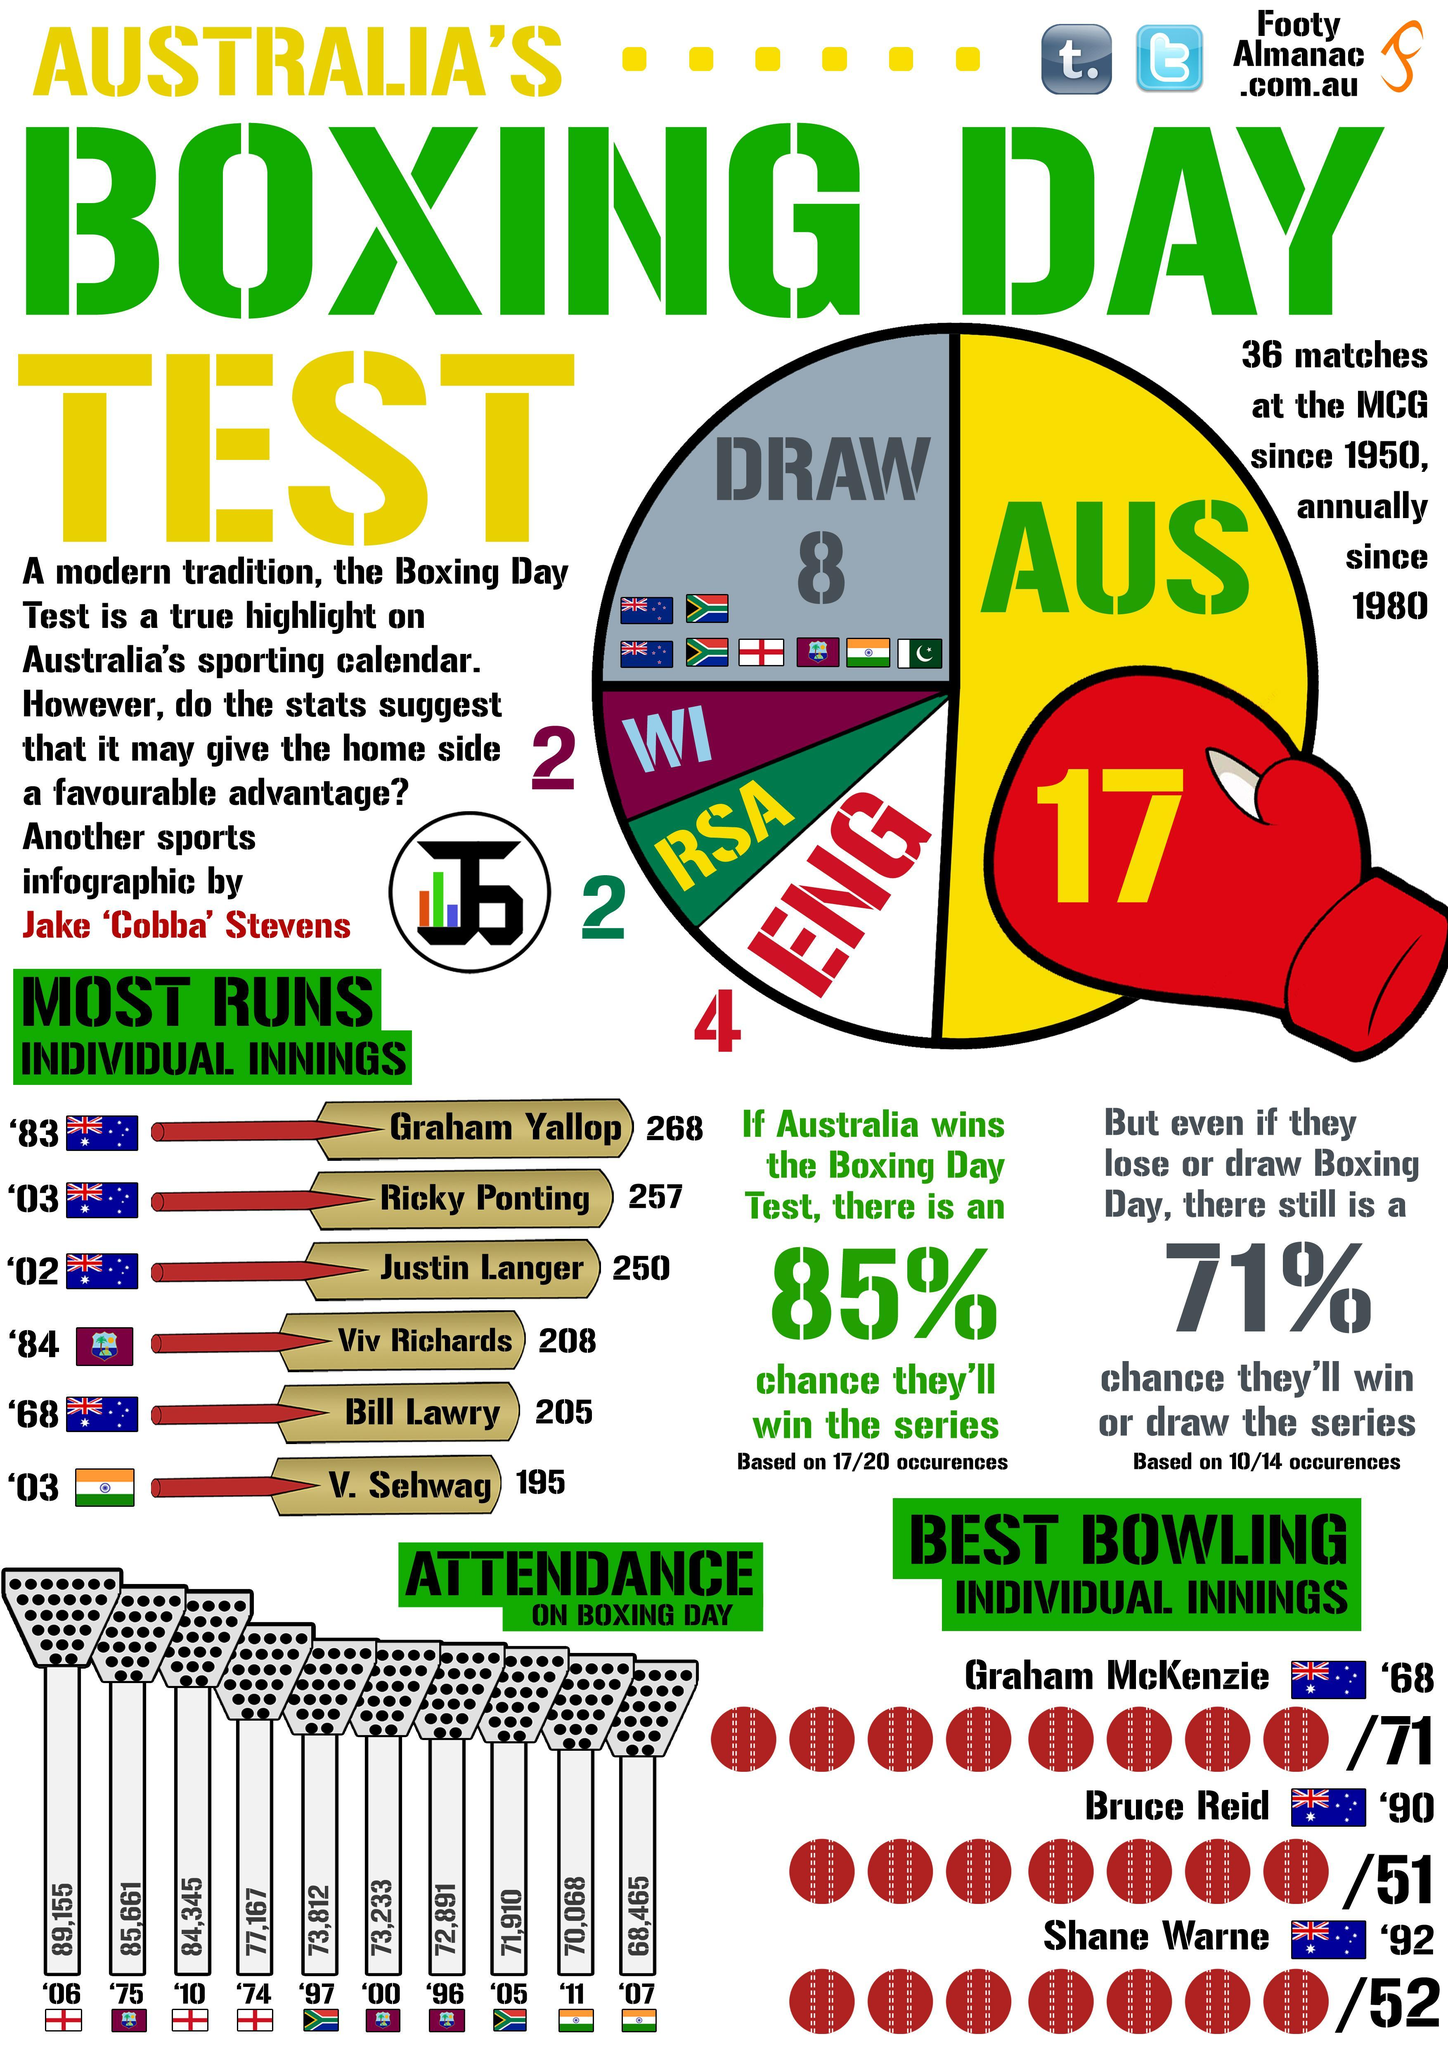What is the run scored by V. Sehwag and Justin Langer, taken together?
Answer the question with a short phrase. 445 What is the run scored by Viv Richards and Bill Lawry, taken together? 413 Which country has the highest number of wins-Eng, Aus, WI? Aus 